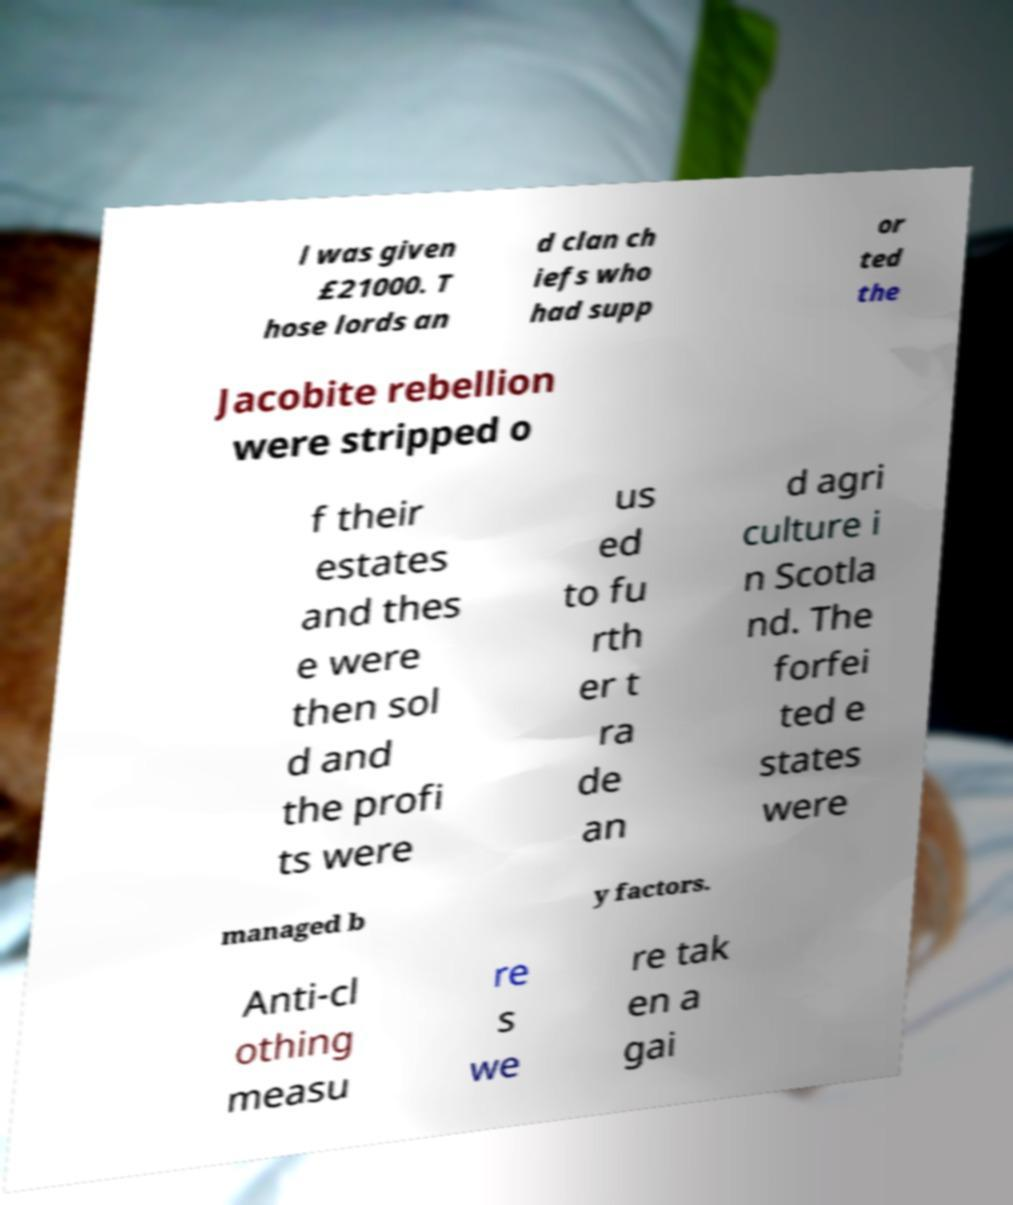Can you read and provide the text displayed in the image?This photo seems to have some interesting text. Can you extract and type it out for me? l was given £21000. T hose lords an d clan ch iefs who had supp or ted the Jacobite rebellion were stripped o f their estates and thes e were then sol d and the profi ts were us ed to fu rth er t ra de an d agri culture i n Scotla nd. The forfei ted e states were managed b y factors. Anti-cl othing measu re s we re tak en a gai 